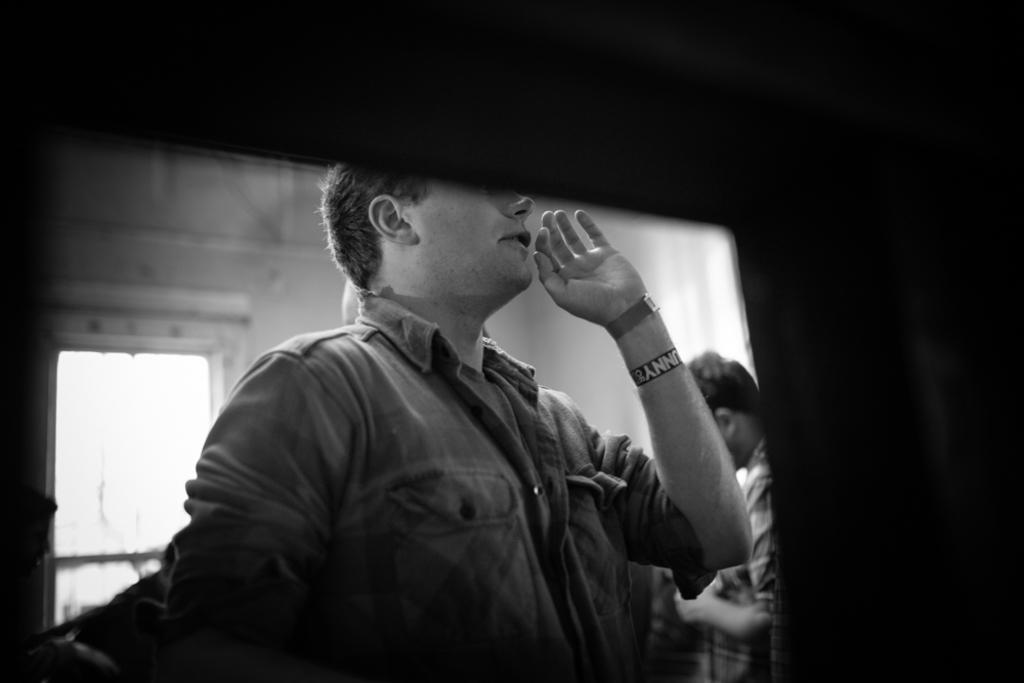Please provide a concise description of this image. In this image it might be the screen, on which there are two persons, entrance gate, wall visible, background is dark. 